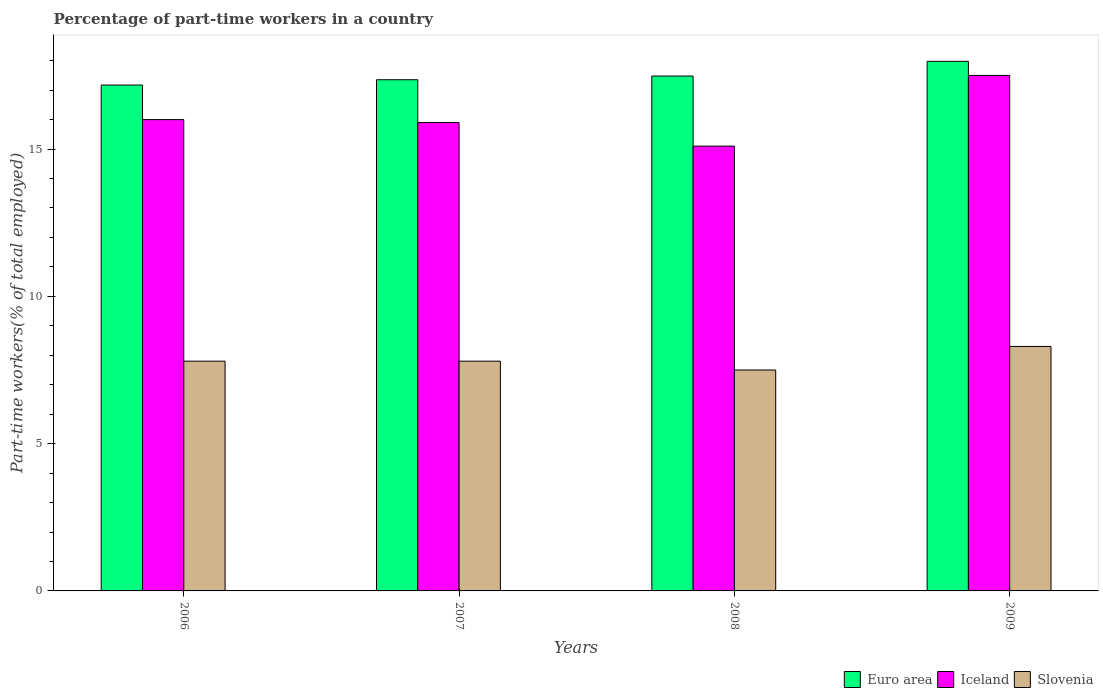How many different coloured bars are there?
Your response must be concise. 3. Are the number of bars on each tick of the X-axis equal?
Keep it short and to the point. Yes. How many bars are there on the 3rd tick from the right?
Your answer should be compact. 3. What is the percentage of part-time workers in Slovenia in 2009?
Give a very brief answer. 8.3. Across all years, what is the maximum percentage of part-time workers in Slovenia?
Ensure brevity in your answer.  8.3. Across all years, what is the minimum percentage of part-time workers in Iceland?
Ensure brevity in your answer.  15.1. What is the total percentage of part-time workers in Iceland in the graph?
Offer a very short reply. 64.5. What is the difference between the percentage of part-time workers in Euro area in 2006 and that in 2008?
Give a very brief answer. -0.31. What is the difference between the percentage of part-time workers in Slovenia in 2008 and the percentage of part-time workers in Euro area in 2007?
Provide a succinct answer. -9.85. What is the average percentage of part-time workers in Slovenia per year?
Your answer should be very brief. 7.85. In the year 2009, what is the difference between the percentage of part-time workers in Euro area and percentage of part-time workers in Slovenia?
Your answer should be compact. 9.68. What is the ratio of the percentage of part-time workers in Euro area in 2007 to that in 2009?
Provide a short and direct response. 0.97. Is the percentage of part-time workers in Slovenia in 2008 less than that in 2009?
Your answer should be compact. Yes. Is the difference between the percentage of part-time workers in Euro area in 2007 and 2008 greater than the difference between the percentage of part-time workers in Slovenia in 2007 and 2008?
Offer a terse response. No. What is the difference between the highest and the second highest percentage of part-time workers in Iceland?
Your answer should be very brief. 1.5. What is the difference between the highest and the lowest percentage of part-time workers in Iceland?
Offer a very short reply. 2.4. What does the 3rd bar from the right in 2009 represents?
Provide a succinct answer. Euro area. Is it the case that in every year, the sum of the percentage of part-time workers in Euro area and percentage of part-time workers in Slovenia is greater than the percentage of part-time workers in Iceland?
Give a very brief answer. Yes. How many bars are there?
Provide a short and direct response. 12. Are all the bars in the graph horizontal?
Offer a very short reply. No. How many years are there in the graph?
Keep it short and to the point. 4. What is the difference between two consecutive major ticks on the Y-axis?
Ensure brevity in your answer.  5. Does the graph contain any zero values?
Your response must be concise. No. Does the graph contain grids?
Offer a terse response. No. Where does the legend appear in the graph?
Your answer should be compact. Bottom right. How many legend labels are there?
Ensure brevity in your answer.  3. How are the legend labels stacked?
Ensure brevity in your answer.  Horizontal. What is the title of the graph?
Your answer should be compact. Percentage of part-time workers in a country. What is the label or title of the X-axis?
Your answer should be compact. Years. What is the label or title of the Y-axis?
Give a very brief answer. Part-time workers(% of total employed). What is the Part-time workers(% of total employed) in Euro area in 2006?
Your answer should be very brief. 17.17. What is the Part-time workers(% of total employed) in Iceland in 2006?
Your answer should be compact. 16. What is the Part-time workers(% of total employed) in Slovenia in 2006?
Ensure brevity in your answer.  7.8. What is the Part-time workers(% of total employed) of Euro area in 2007?
Ensure brevity in your answer.  17.35. What is the Part-time workers(% of total employed) in Iceland in 2007?
Ensure brevity in your answer.  15.9. What is the Part-time workers(% of total employed) of Slovenia in 2007?
Keep it short and to the point. 7.8. What is the Part-time workers(% of total employed) of Euro area in 2008?
Offer a very short reply. 17.48. What is the Part-time workers(% of total employed) of Iceland in 2008?
Ensure brevity in your answer.  15.1. What is the Part-time workers(% of total employed) in Slovenia in 2008?
Provide a short and direct response. 7.5. What is the Part-time workers(% of total employed) in Euro area in 2009?
Provide a succinct answer. 17.98. What is the Part-time workers(% of total employed) in Slovenia in 2009?
Your answer should be very brief. 8.3. Across all years, what is the maximum Part-time workers(% of total employed) in Euro area?
Your answer should be very brief. 17.98. Across all years, what is the maximum Part-time workers(% of total employed) in Iceland?
Ensure brevity in your answer.  17.5. Across all years, what is the maximum Part-time workers(% of total employed) of Slovenia?
Your answer should be compact. 8.3. Across all years, what is the minimum Part-time workers(% of total employed) of Euro area?
Make the answer very short. 17.17. Across all years, what is the minimum Part-time workers(% of total employed) in Iceland?
Give a very brief answer. 15.1. Across all years, what is the minimum Part-time workers(% of total employed) of Slovenia?
Provide a short and direct response. 7.5. What is the total Part-time workers(% of total employed) of Euro area in the graph?
Provide a short and direct response. 69.99. What is the total Part-time workers(% of total employed) of Iceland in the graph?
Your answer should be compact. 64.5. What is the total Part-time workers(% of total employed) of Slovenia in the graph?
Your response must be concise. 31.4. What is the difference between the Part-time workers(% of total employed) of Euro area in 2006 and that in 2007?
Make the answer very short. -0.18. What is the difference between the Part-time workers(% of total employed) of Slovenia in 2006 and that in 2007?
Offer a very short reply. 0. What is the difference between the Part-time workers(% of total employed) of Euro area in 2006 and that in 2008?
Provide a short and direct response. -0.31. What is the difference between the Part-time workers(% of total employed) in Iceland in 2006 and that in 2008?
Make the answer very short. 0.9. What is the difference between the Part-time workers(% of total employed) of Euro area in 2006 and that in 2009?
Make the answer very short. -0.8. What is the difference between the Part-time workers(% of total employed) of Iceland in 2006 and that in 2009?
Your response must be concise. -1.5. What is the difference between the Part-time workers(% of total employed) of Euro area in 2007 and that in 2008?
Give a very brief answer. -0.13. What is the difference between the Part-time workers(% of total employed) in Iceland in 2007 and that in 2008?
Your response must be concise. 0.8. What is the difference between the Part-time workers(% of total employed) of Euro area in 2007 and that in 2009?
Your response must be concise. -0.62. What is the difference between the Part-time workers(% of total employed) of Euro area in 2008 and that in 2009?
Your response must be concise. -0.5. What is the difference between the Part-time workers(% of total employed) in Iceland in 2008 and that in 2009?
Ensure brevity in your answer.  -2.4. What is the difference between the Part-time workers(% of total employed) in Euro area in 2006 and the Part-time workers(% of total employed) in Iceland in 2007?
Ensure brevity in your answer.  1.27. What is the difference between the Part-time workers(% of total employed) in Euro area in 2006 and the Part-time workers(% of total employed) in Slovenia in 2007?
Keep it short and to the point. 9.37. What is the difference between the Part-time workers(% of total employed) in Euro area in 2006 and the Part-time workers(% of total employed) in Iceland in 2008?
Provide a succinct answer. 2.07. What is the difference between the Part-time workers(% of total employed) of Euro area in 2006 and the Part-time workers(% of total employed) of Slovenia in 2008?
Offer a terse response. 9.67. What is the difference between the Part-time workers(% of total employed) of Euro area in 2006 and the Part-time workers(% of total employed) of Iceland in 2009?
Your response must be concise. -0.33. What is the difference between the Part-time workers(% of total employed) of Euro area in 2006 and the Part-time workers(% of total employed) of Slovenia in 2009?
Your response must be concise. 8.87. What is the difference between the Part-time workers(% of total employed) of Iceland in 2006 and the Part-time workers(% of total employed) of Slovenia in 2009?
Your response must be concise. 7.7. What is the difference between the Part-time workers(% of total employed) in Euro area in 2007 and the Part-time workers(% of total employed) in Iceland in 2008?
Make the answer very short. 2.25. What is the difference between the Part-time workers(% of total employed) of Euro area in 2007 and the Part-time workers(% of total employed) of Slovenia in 2008?
Your answer should be very brief. 9.85. What is the difference between the Part-time workers(% of total employed) in Iceland in 2007 and the Part-time workers(% of total employed) in Slovenia in 2008?
Provide a succinct answer. 8.4. What is the difference between the Part-time workers(% of total employed) of Euro area in 2007 and the Part-time workers(% of total employed) of Iceland in 2009?
Your answer should be compact. -0.15. What is the difference between the Part-time workers(% of total employed) of Euro area in 2007 and the Part-time workers(% of total employed) of Slovenia in 2009?
Provide a succinct answer. 9.05. What is the difference between the Part-time workers(% of total employed) of Euro area in 2008 and the Part-time workers(% of total employed) of Iceland in 2009?
Ensure brevity in your answer.  -0.02. What is the difference between the Part-time workers(% of total employed) of Euro area in 2008 and the Part-time workers(% of total employed) of Slovenia in 2009?
Offer a very short reply. 9.18. What is the difference between the Part-time workers(% of total employed) of Iceland in 2008 and the Part-time workers(% of total employed) of Slovenia in 2009?
Your answer should be compact. 6.8. What is the average Part-time workers(% of total employed) of Euro area per year?
Ensure brevity in your answer.  17.5. What is the average Part-time workers(% of total employed) of Iceland per year?
Your response must be concise. 16.12. What is the average Part-time workers(% of total employed) of Slovenia per year?
Ensure brevity in your answer.  7.85. In the year 2006, what is the difference between the Part-time workers(% of total employed) of Euro area and Part-time workers(% of total employed) of Iceland?
Make the answer very short. 1.17. In the year 2006, what is the difference between the Part-time workers(% of total employed) of Euro area and Part-time workers(% of total employed) of Slovenia?
Your answer should be very brief. 9.37. In the year 2007, what is the difference between the Part-time workers(% of total employed) of Euro area and Part-time workers(% of total employed) of Iceland?
Your answer should be compact. 1.45. In the year 2007, what is the difference between the Part-time workers(% of total employed) in Euro area and Part-time workers(% of total employed) in Slovenia?
Provide a short and direct response. 9.55. In the year 2008, what is the difference between the Part-time workers(% of total employed) in Euro area and Part-time workers(% of total employed) in Iceland?
Offer a terse response. 2.38. In the year 2008, what is the difference between the Part-time workers(% of total employed) in Euro area and Part-time workers(% of total employed) in Slovenia?
Offer a terse response. 9.98. In the year 2008, what is the difference between the Part-time workers(% of total employed) of Iceland and Part-time workers(% of total employed) of Slovenia?
Your answer should be very brief. 7.6. In the year 2009, what is the difference between the Part-time workers(% of total employed) in Euro area and Part-time workers(% of total employed) in Iceland?
Ensure brevity in your answer.  0.48. In the year 2009, what is the difference between the Part-time workers(% of total employed) in Euro area and Part-time workers(% of total employed) in Slovenia?
Offer a terse response. 9.68. In the year 2009, what is the difference between the Part-time workers(% of total employed) in Iceland and Part-time workers(% of total employed) in Slovenia?
Keep it short and to the point. 9.2. What is the ratio of the Part-time workers(% of total employed) in Slovenia in 2006 to that in 2007?
Make the answer very short. 1. What is the ratio of the Part-time workers(% of total employed) in Euro area in 2006 to that in 2008?
Keep it short and to the point. 0.98. What is the ratio of the Part-time workers(% of total employed) in Iceland in 2006 to that in 2008?
Your answer should be very brief. 1.06. What is the ratio of the Part-time workers(% of total employed) in Slovenia in 2006 to that in 2008?
Keep it short and to the point. 1.04. What is the ratio of the Part-time workers(% of total employed) in Euro area in 2006 to that in 2009?
Provide a short and direct response. 0.96. What is the ratio of the Part-time workers(% of total employed) of Iceland in 2006 to that in 2009?
Ensure brevity in your answer.  0.91. What is the ratio of the Part-time workers(% of total employed) in Slovenia in 2006 to that in 2009?
Provide a succinct answer. 0.94. What is the ratio of the Part-time workers(% of total employed) in Iceland in 2007 to that in 2008?
Offer a very short reply. 1.05. What is the ratio of the Part-time workers(% of total employed) of Slovenia in 2007 to that in 2008?
Provide a succinct answer. 1.04. What is the ratio of the Part-time workers(% of total employed) of Euro area in 2007 to that in 2009?
Provide a short and direct response. 0.97. What is the ratio of the Part-time workers(% of total employed) of Iceland in 2007 to that in 2009?
Your answer should be very brief. 0.91. What is the ratio of the Part-time workers(% of total employed) of Slovenia in 2007 to that in 2009?
Offer a very short reply. 0.94. What is the ratio of the Part-time workers(% of total employed) in Euro area in 2008 to that in 2009?
Your answer should be compact. 0.97. What is the ratio of the Part-time workers(% of total employed) of Iceland in 2008 to that in 2009?
Your response must be concise. 0.86. What is the ratio of the Part-time workers(% of total employed) in Slovenia in 2008 to that in 2009?
Give a very brief answer. 0.9. What is the difference between the highest and the second highest Part-time workers(% of total employed) in Euro area?
Give a very brief answer. 0.5. What is the difference between the highest and the second highest Part-time workers(% of total employed) in Iceland?
Offer a very short reply. 1.5. What is the difference between the highest and the lowest Part-time workers(% of total employed) in Euro area?
Offer a terse response. 0.8. 